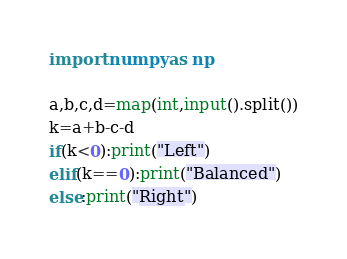Convert code to text. <code><loc_0><loc_0><loc_500><loc_500><_Python_>

import numpy as np

a,b,c,d=map(int,input().split())
k=a+b-c-d
if(k<0):print("Left")
elif(k==0):print("Balanced")
else:print("Right")
</code> 